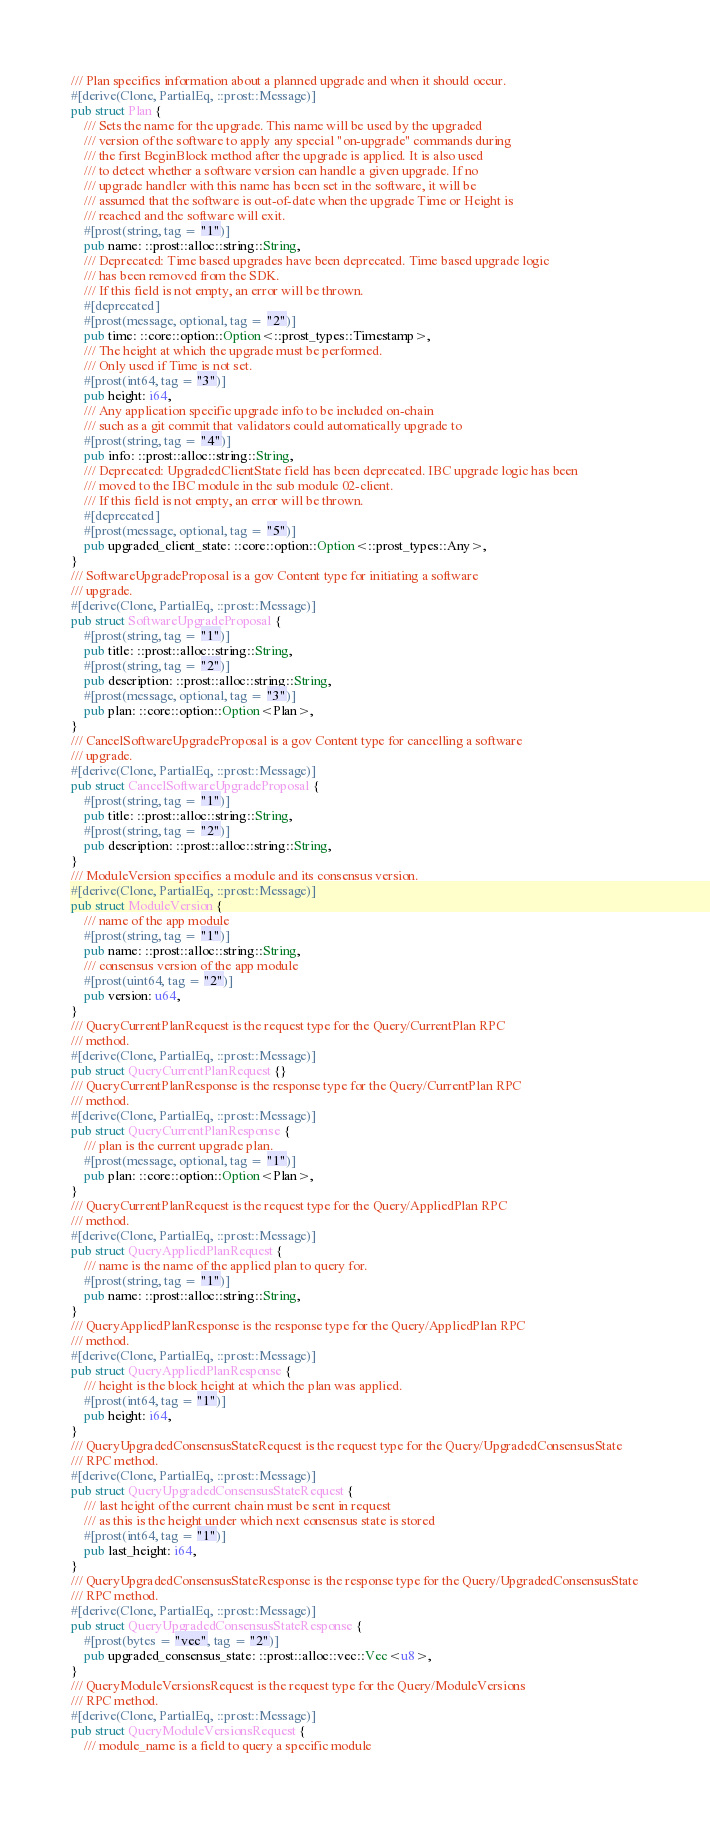<code> <loc_0><loc_0><loc_500><loc_500><_Rust_>/// Plan specifies information about a planned upgrade and when it should occur.
#[derive(Clone, PartialEq, ::prost::Message)]
pub struct Plan {
    /// Sets the name for the upgrade. This name will be used by the upgraded
    /// version of the software to apply any special "on-upgrade" commands during
    /// the first BeginBlock method after the upgrade is applied. It is also used
    /// to detect whether a software version can handle a given upgrade. If no
    /// upgrade handler with this name has been set in the software, it will be
    /// assumed that the software is out-of-date when the upgrade Time or Height is
    /// reached and the software will exit.
    #[prost(string, tag = "1")]
    pub name: ::prost::alloc::string::String,
    /// Deprecated: Time based upgrades have been deprecated. Time based upgrade logic
    /// has been removed from the SDK.
    /// If this field is not empty, an error will be thrown.
    #[deprecated]
    #[prost(message, optional, tag = "2")]
    pub time: ::core::option::Option<::prost_types::Timestamp>,
    /// The height at which the upgrade must be performed.
    /// Only used if Time is not set.
    #[prost(int64, tag = "3")]
    pub height: i64,
    /// Any application specific upgrade info to be included on-chain
    /// such as a git commit that validators could automatically upgrade to
    #[prost(string, tag = "4")]
    pub info: ::prost::alloc::string::String,
    /// Deprecated: UpgradedClientState field has been deprecated. IBC upgrade logic has been
    /// moved to the IBC module in the sub module 02-client.
    /// If this field is not empty, an error will be thrown.
    #[deprecated]
    #[prost(message, optional, tag = "5")]
    pub upgraded_client_state: ::core::option::Option<::prost_types::Any>,
}
/// SoftwareUpgradeProposal is a gov Content type for initiating a software
/// upgrade.
#[derive(Clone, PartialEq, ::prost::Message)]
pub struct SoftwareUpgradeProposal {
    #[prost(string, tag = "1")]
    pub title: ::prost::alloc::string::String,
    #[prost(string, tag = "2")]
    pub description: ::prost::alloc::string::String,
    #[prost(message, optional, tag = "3")]
    pub plan: ::core::option::Option<Plan>,
}
/// CancelSoftwareUpgradeProposal is a gov Content type for cancelling a software
/// upgrade.
#[derive(Clone, PartialEq, ::prost::Message)]
pub struct CancelSoftwareUpgradeProposal {
    #[prost(string, tag = "1")]
    pub title: ::prost::alloc::string::String,
    #[prost(string, tag = "2")]
    pub description: ::prost::alloc::string::String,
}
/// ModuleVersion specifies a module and its consensus version.
#[derive(Clone, PartialEq, ::prost::Message)]
pub struct ModuleVersion {
    /// name of the app module
    #[prost(string, tag = "1")]
    pub name: ::prost::alloc::string::String,
    /// consensus version of the app module
    #[prost(uint64, tag = "2")]
    pub version: u64,
}
/// QueryCurrentPlanRequest is the request type for the Query/CurrentPlan RPC
/// method.
#[derive(Clone, PartialEq, ::prost::Message)]
pub struct QueryCurrentPlanRequest {}
/// QueryCurrentPlanResponse is the response type for the Query/CurrentPlan RPC
/// method.
#[derive(Clone, PartialEq, ::prost::Message)]
pub struct QueryCurrentPlanResponse {
    /// plan is the current upgrade plan.
    #[prost(message, optional, tag = "1")]
    pub plan: ::core::option::Option<Plan>,
}
/// QueryCurrentPlanRequest is the request type for the Query/AppliedPlan RPC
/// method.
#[derive(Clone, PartialEq, ::prost::Message)]
pub struct QueryAppliedPlanRequest {
    /// name is the name of the applied plan to query for.
    #[prost(string, tag = "1")]
    pub name: ::prost::alloc::string::String,
}
/// QueryAppliedPlanResponse is the response type for the Query/AppliedPlan RPC
/// method.
#[derive(Clone, PartialEq, ::prost::Message)]
pub struct QueryAppliedPlanResponse {
    /// height is the block height at which the plan was applied.
    #[prost(int64, tag = "1")]
    pub height: i64,
}
/// QueryUpgradedConsensusStateRequest is the request type for the Query/UpgradedConsensusState
/// RPC method.
#[derive(Clone, PartialEq, ::prost::Message)]
pub struct QueryUpgradedConsensusStateRequest {
    /// last height of the current chain must be sent in request
    /// as this is the height under which next consensus state is stored
    #[prost(int64, tag = "1")]
    pub last_height: i64,
}
/// QueryUpgradedConsensusStateResponse is the response type for the Query/UpgradedConsensusState
/// RPC method.
#[derive(Clone, PartialEq, ::prost::Message)]
pub struct QueryUpgradedConsensusStateResponse {
    #[prost(bytes = "vec", tag = "2")]
    pub upgraded_consensus_state: ::prost::alloc::vec::Vec<u8>,
}
/// QueryModuleVersionsRequest is the request type for the Query/ModuleVersions
/// RPC method.
#[derive(Clone, PartialEq, ::prost::Message)]
pub struct QueryModuleVersionsRequest {
    /// module_name is a field to query a specific module</code> 